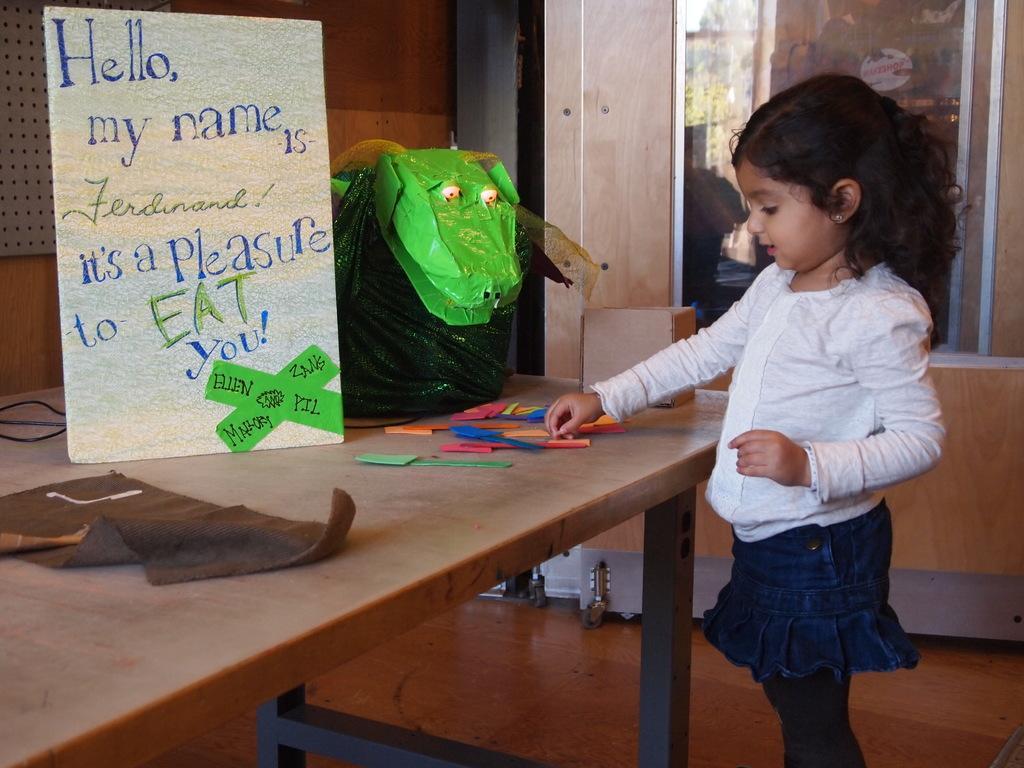Please provide a concise description of this image. This picture is inside a room. in the right hand side a little girl is standing. In front of her there is a table. On the table there are some toys ,paper. In the background there is a mirror. 